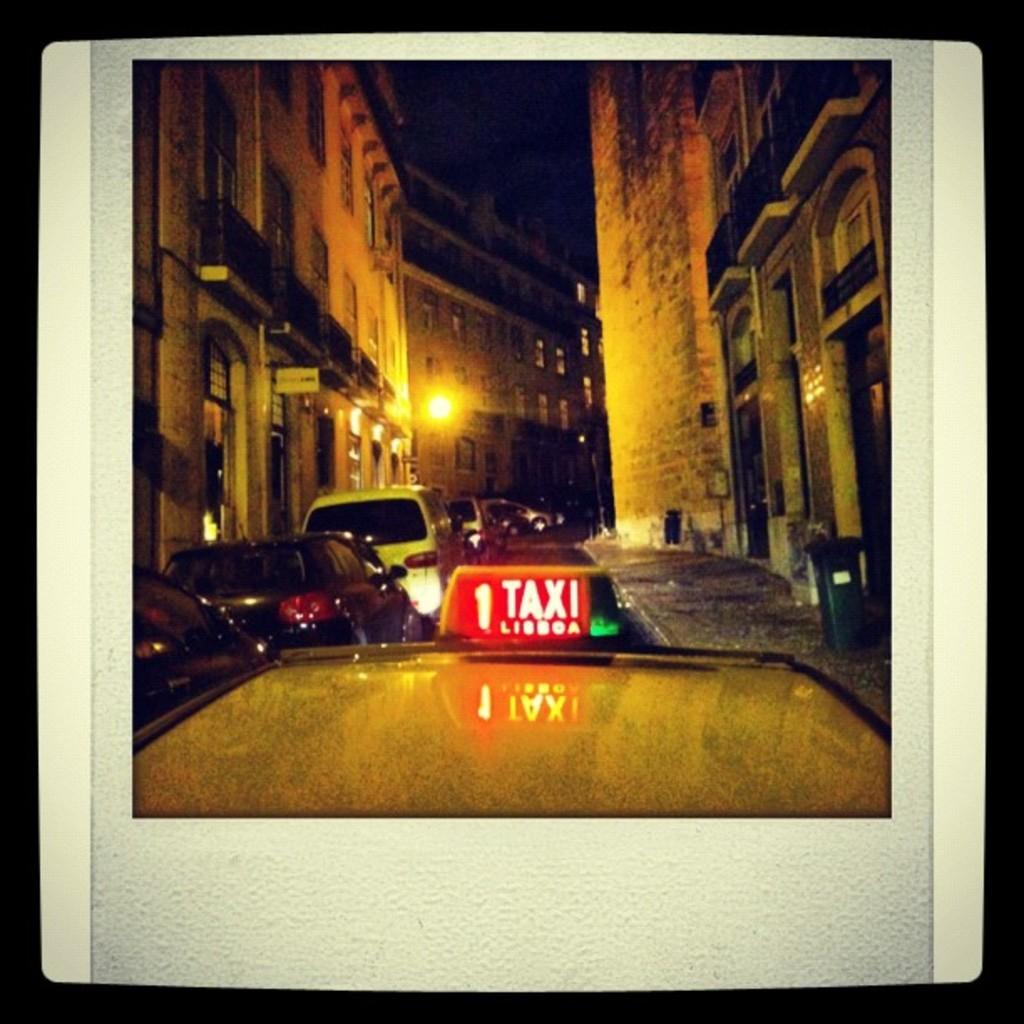What can be seen in the image? There are vehicles in the image. Where are the buildings located in the image? There are buildings on both the left and right sides of the image. Can you describe the lighting in the image? There is light visible in the image. Are there any balls visible in the garden in the image? There is no garden or balls present in the image. 